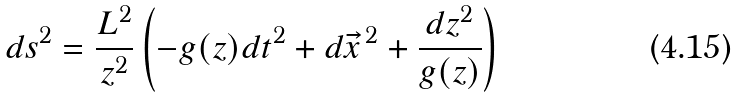<formula> <loc_0><loc_0><loc_500><loc_500>\ d s ^ { 2 } = \frac { L ^ { 2 } } { z ^ { 2 } } \left ( - g ( z ) d t ^ { 2 } + d \vec { x } ^ { \, 2 } + \frac { d z ^ { 2 } } { g ( z ) } \right )</formula> 